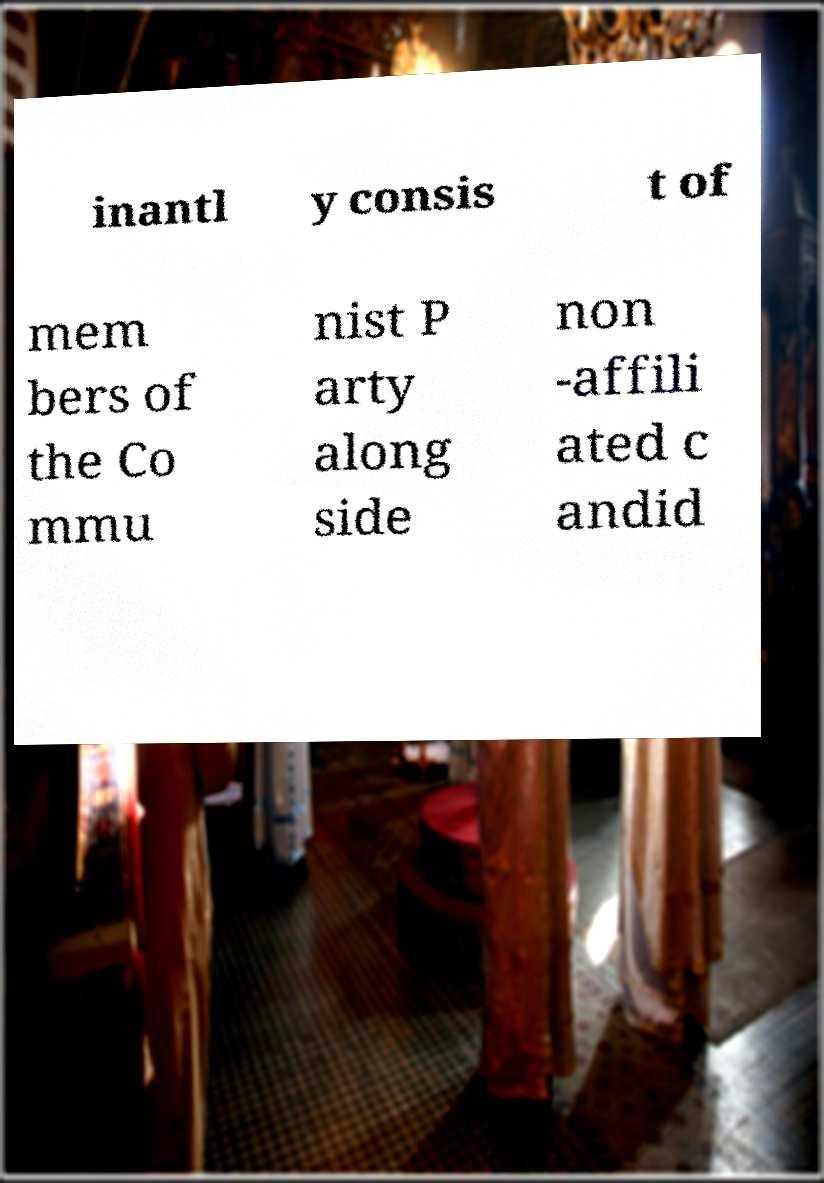Please identify and transcribe the text found in this image. inantl y consis t of mem bers of the Co mmu nist P arty along side non -affili ated c andid 